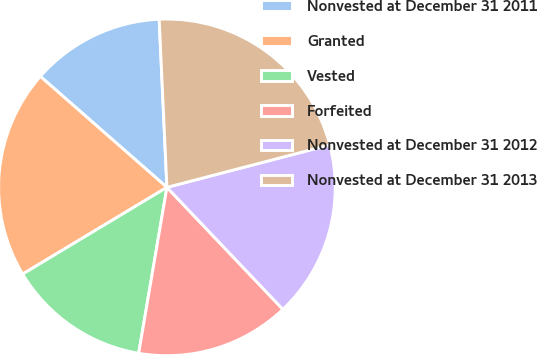<chart> <loc_0><loc_0><loc_500><loc_500><pie_chart><fcel>Nonvested at December 31 2011<fcel>Granted<fcel>Vested<fcel>Forfeited<fcel>Nonvested at December 31 2012<fcel>Nonvested at December 31 2013<nl><fcel>12.81%<fcel>20.07%<fcel>13.7%<fcel>14.78%<fcel>16.96%<fcel>21.67%<nl></chart> 